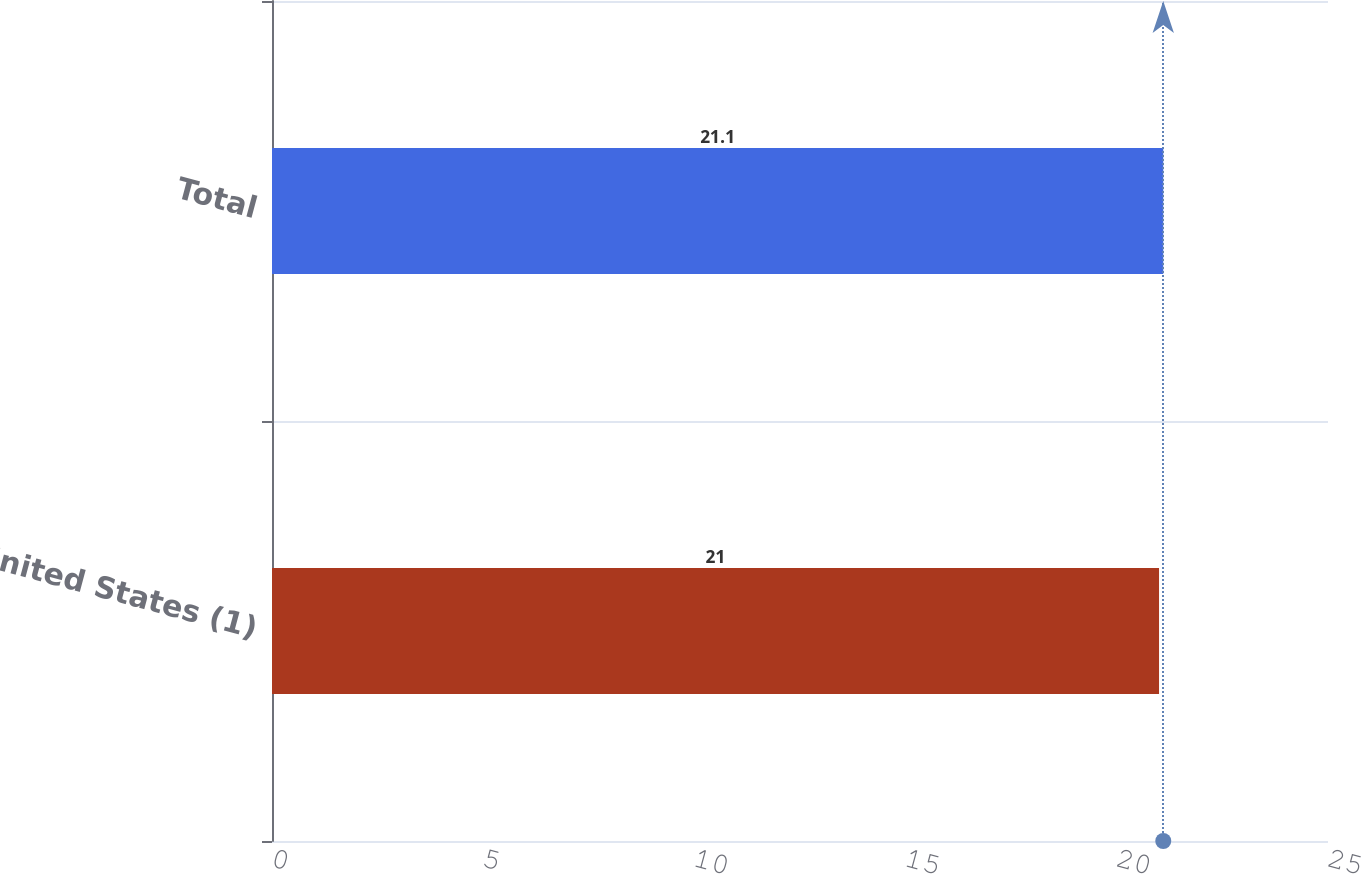Convert chart. <chart><loc_0><loc_0><loc_500><loc_500><bar_chart><fcel>United States (1)<fcel>Total<nl><fcel>21<fcel>21.1<nl></chart> 